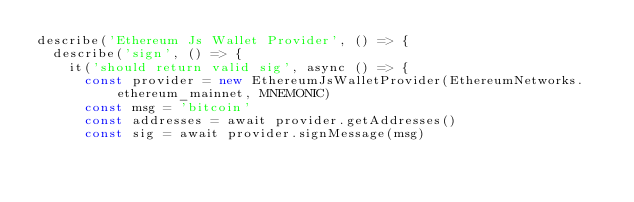Convert code to text. <code><loc_0><loc_0><loc_500><loc_500><_TypeScript_>describe('Ethereum Js Wallet Provider', () => {
  describe('sign', () => {
    it('should return valid sig', async () => {
      const provider = new EthereumJsWalletProvider(EthereumNetworks.ethereum_mainnet, MNEMONIC)
      const msg = 'bitcoin'
      const addresses = await provider.getAddresses()
      const sig = await provider.signMessage(msg)</code> 